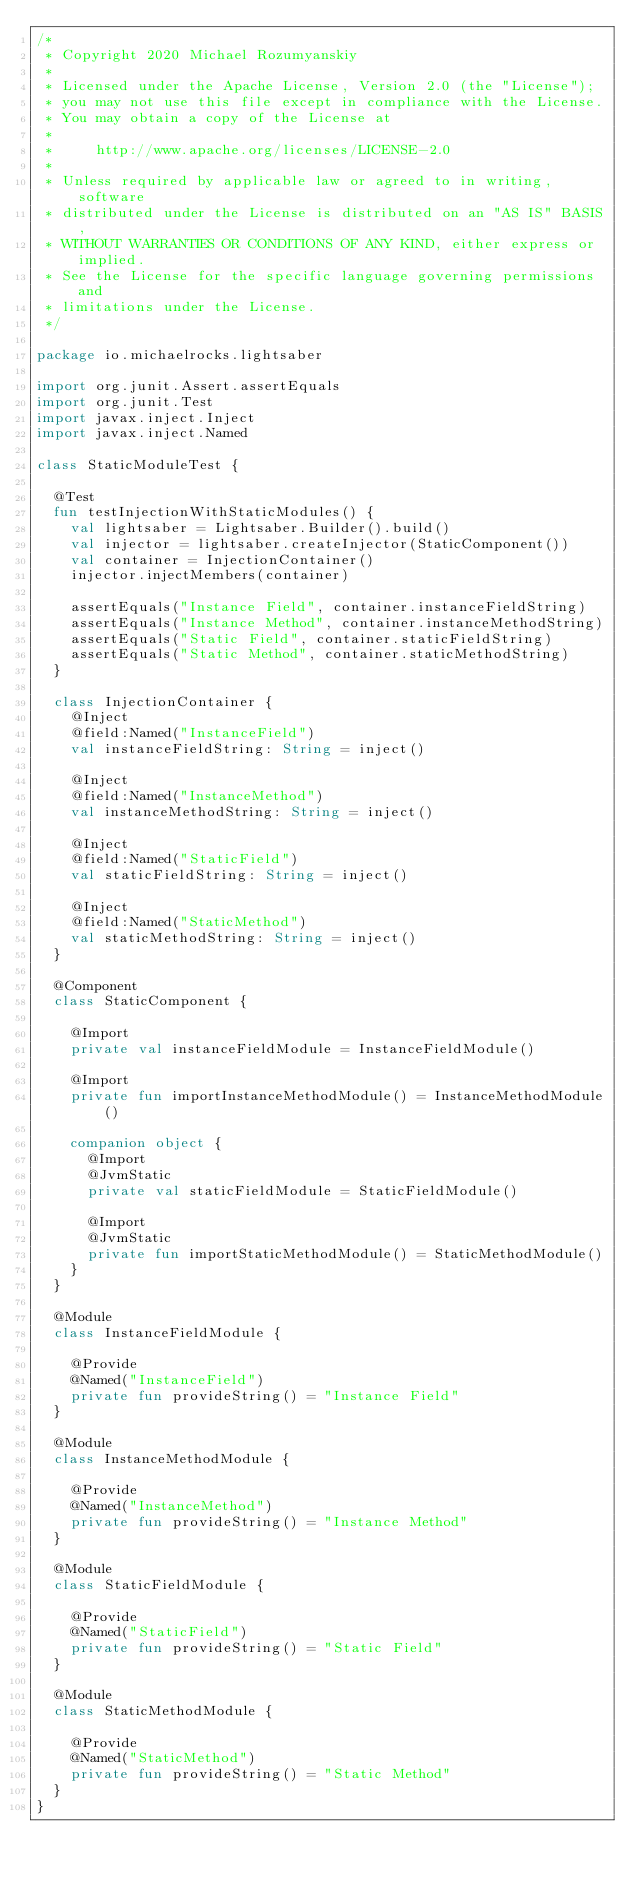Convert code to text. <code><loc_0><loc_0><loc_500><loc_500><_Kotlin_>/*
 * Copyright 2020 Michael Rozumyanskiy
 *
 * Licensed under the Apache License, Version 2.0 (the "License");
 * you may not use this file except in compliance with the License.
 * You may obtain a copy of the License at
 *
 *     http://www.apache.org/licenses/LICENSE-2.0
 *
 * Unless required by applicable law or agreed to in writing, software
 * distributed under the License is distributed on an "AS IS" BASIS,
 * WITHOUT WARRANTIES OR CONDITIONS OF ANY KIND, either express or implied.
 * See the License for the specific language governing permissions and
 * limitations under the License.
 */

package io.michaelrocks.lightsaber

import org.junit.Assert.assertEquals
import org.junit.Test
import javax.inject.Inject
import javax.inject.Named

class StaticModuleTest {

  @Test
  fun testInjectionWithStaticModules() {
    val lightsaber = Lightsaber.Builder().build()
    val injector = lightsaber.createInjector(StaticComponent())
    val container = InjectionContainer()
    injector.injectMembers(container)

    assertEquals("Instance Field", container.instanceFieldString)
    assertEquals("Instance Method", container.instanceMethodString)
    assertEquals("Static Field", container.staticFieldString)
    assertEquals("Static Method", container.staticMethodString)
  }

  class InjectionContainer {
    @Inject
    @field:Named("InstanceField")
    val instanceFieldString: String = inject()

    @Inject
    @field:Named("InstanceMethod")
    val instanceMethodString: String = inject()

    @Inject
    @field:Named("StaticField")
    val staticFieldString: String = inject()

    @Inject
    @field:Named("StaticMethod")
    val staticMethodString: String = inject()
  }

  @Component
  class StaticComponent {

    @Import
    private val instanceFieldModule = InstanceFieldModule()

    @Import
    private fun importInstanceMethodModule() = InstanceMethodModule()

    companion object {
      @Import
      @JvmStatic
      private val staticFieldModule = StaticFieldModule()

      @Import
      @JvmStatic
      private fun importStaticMethodModule() = StaticMethodModule()
    }
  }

  @Module
  class InstanceFieldModule {

    @Provide
    @Named("InstanceField")
    private fun provideString() = "Instance Field"
  }

  @Module
  class InstanceMethodModule {

    @Provide
    @Named("InstanceMethod")
    private fun provideString() = "Instance Method"
  }

  @Module
  class StaticFieldModule {

    @Provide
    @Named("StaticField")
    private fun provideString() = "Static Field"
  }

  @Module
  class StaticMethodModule {

    @Provide
    @Named("StaticMethod")
    private fun provideString() = "Static Method"
  }
}
</code> 